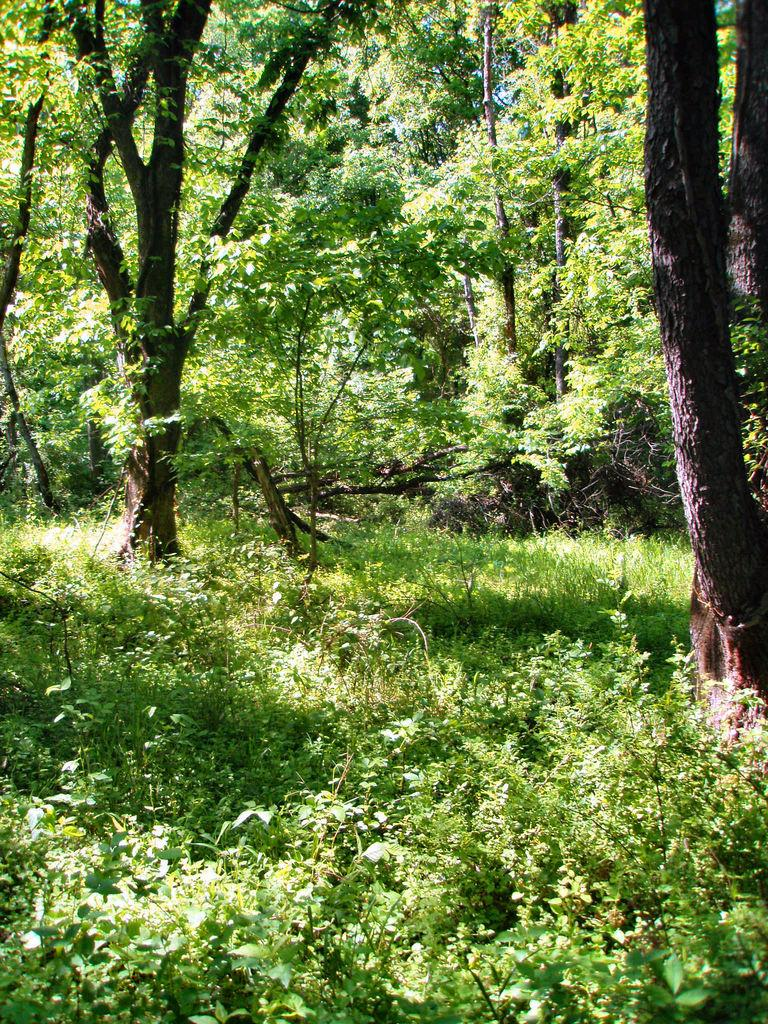What types of vegetation are at the bottom of the image? There are at the bottom of the image? What can be seen in the background of the image? There are trees in the background of the image. What is the name of the basin in the image? There is no basin present in the image. How many sisters are visible in the image? There are no people, including sisters, present in the image. 